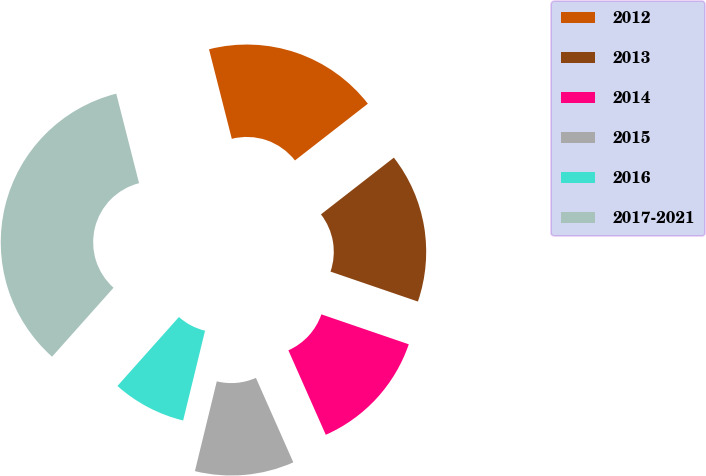Convert chart. <chart><loc_0><loc_0><loc_500><loc_500><pie_chart><fcel>2012<fcel>2013<fcel>2014<fcel>2015<fcel>2016<fcel>2017-2021<nl><fcel>18.44%<fcel>15.78%<fcel>13.11%<fcel>10.44%<fcel>7.78%<fcel>34.44%<nl></chart> 